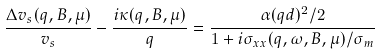Convert formula to latex. <formula><loc_0><loc_0><loc_500><loc_500>\frac { \Delta v _ { s } ( q , B , \mu ) } { v _ { s } } - \frac { i \kappa ( q , B , \mu ) } { q } = \frac { \alpha ( q d ) ^ { 2 } / 2 } { 1 + i \sigma _ { x x } ( q , \omega , B , \mu ) / \sigma _ { m } }</formula> 